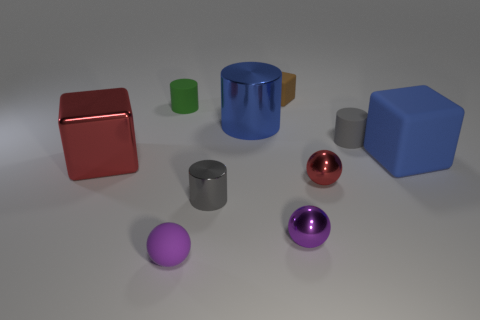There is a tiny object that is both behind the red metallic ball and on the right side of the small brown thing; what is its color?
Provide a succinct answer. Gray. The tiny gray thing that is made of the same material as the tiny green cylinder is what shape?
Make the answer very short. Cylinder. What number of cubes are in front of the green cylinder and behind the tiny green object?
Make the answer very short. 0. Are there any tiny purple balls in front of the green object?
Offer a very short reply. Yes. Is the shape of the big metal object that is to the right of the red shiny cube the same as the large metallic object that is to the left of the small green matte cylinder?
Provide a short and direct response. No. How many objects are large blue rubber objects or cylinders behind the big red metal thing?
Make the answer very short. 4. What number of other objects are the same shape as the tiny purple matte object?
Ensure brevity in your answer.  2. Is the red thing that is left of the purple rubber object made of the same material as the green cylinder?
Give a very brief answer. No. How many objects are either red spheres or matte spheres?
Make the answer very short. 2. There is a gray rubber thing that is the same shape as the big blue metal thing; what is its size?
Offer a very short reply. Small. 